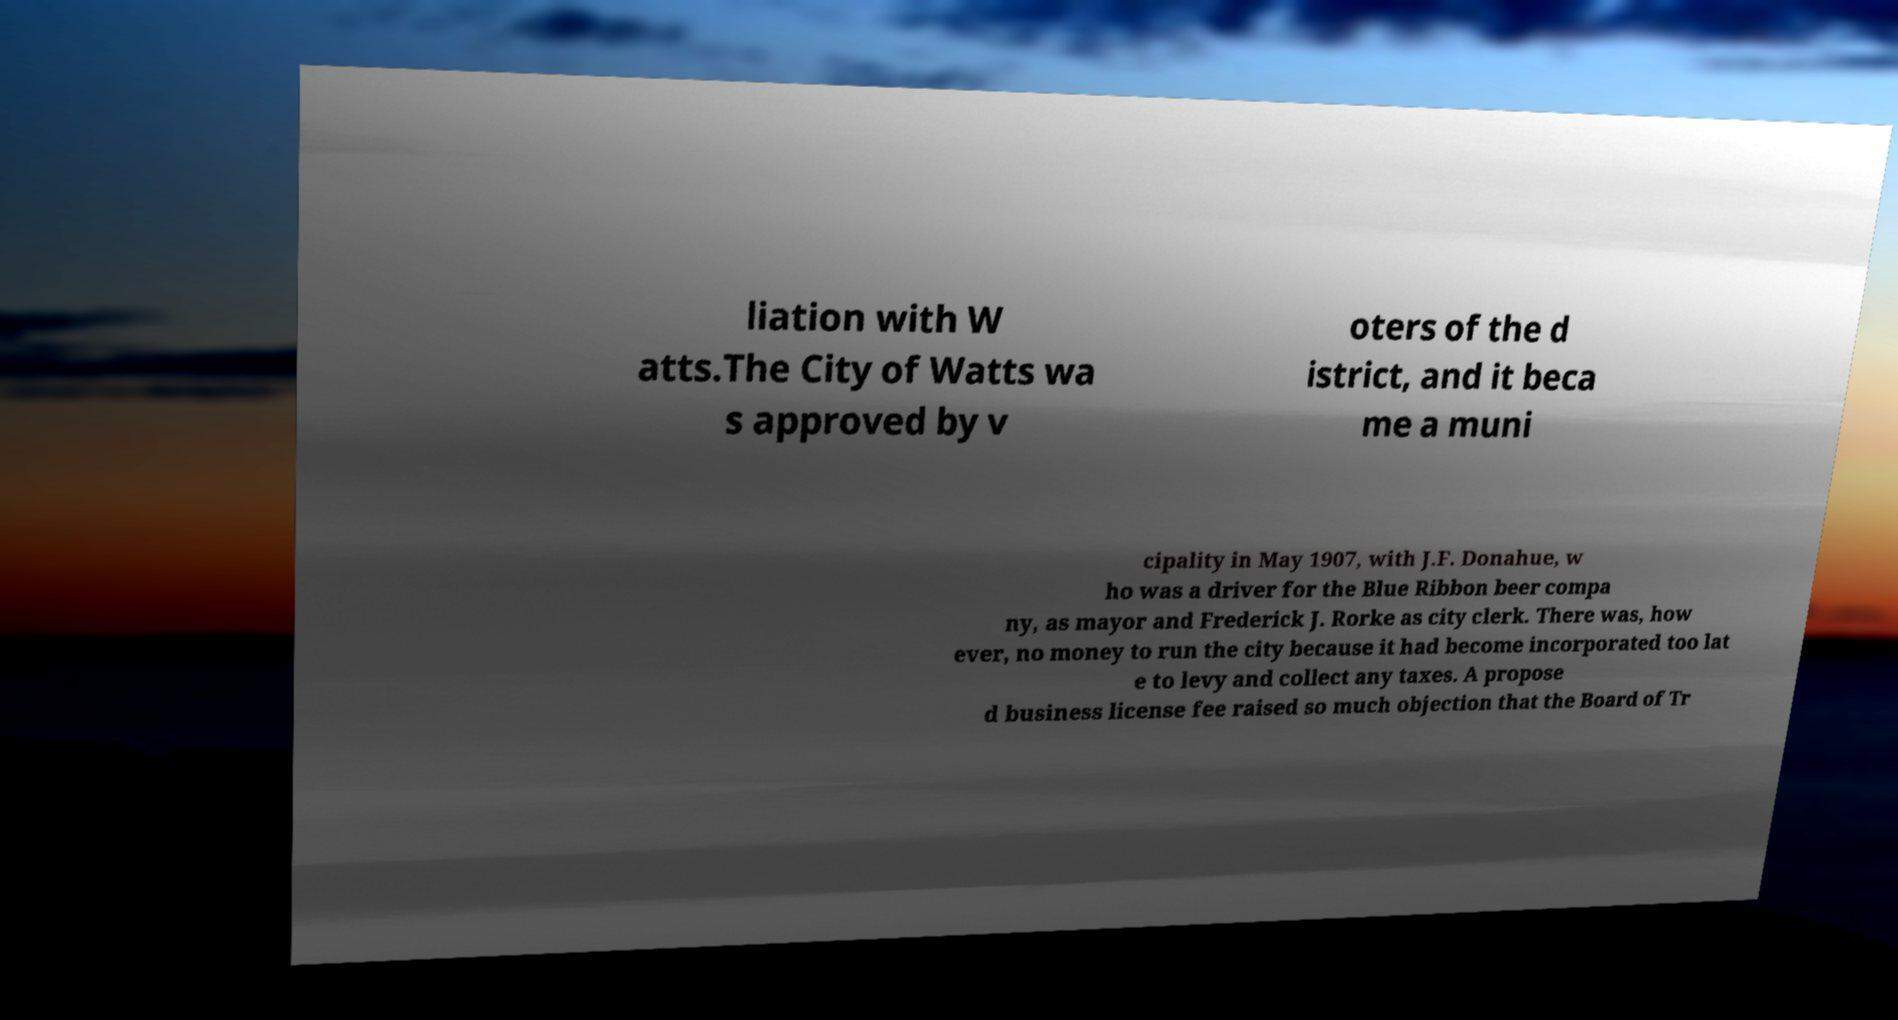Could you assist in decoding the text presented in this image and type it out clearly? liation with W atts.The City of Watts wa s approved by v oters of the d istrict, and it beca me a muni cipality in May 1907, with J.F. Donahue, w ho was a driver for the Blue Ribbon beer compa ny, as mayor and Frederick J. Rorke as city clerk. There was, how ever, no money to run the city because it had become incorporated too lat e to levy and collect any taxes. A propose d business license fee raised so much objection that the Board of Tr 